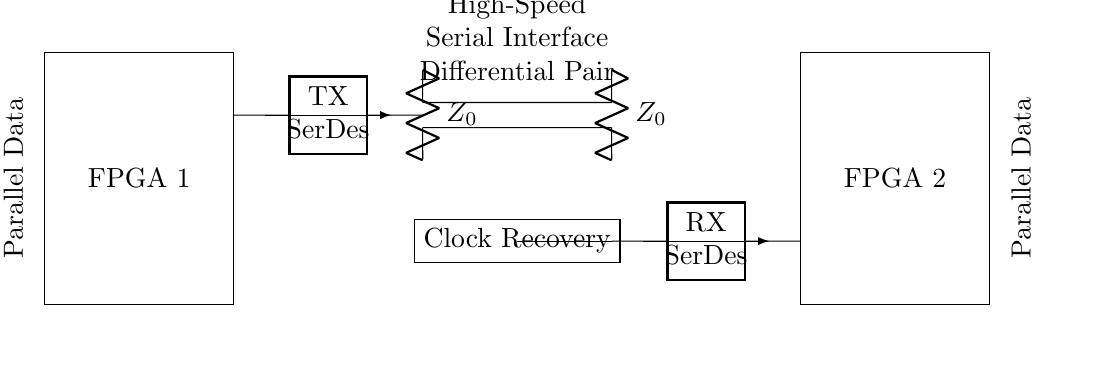What types of FPGAs are in the diagram? The circuit diagram shows two FPGAs labeled as FPGA 1 and FPGA 2. They are each represented as rectangles, and the labeling indicates their functions.
Answer: FPGA 1 and FPGA 2 What is the purpose of the SerDes in this circuit? The SerDes shown in the circuit diagram is responsible for serializing and deserializing data. This is indicated by the labels TX for the transmitter and RX for the receiver, which highlight the direction of data flow.
Answer: Serializing and deserializing data What does the "Differential Pair" signify? The "Differential Pair" refers to two signal lines used to transmit data differentially, which is seen in the two short connections between the SerDes of FPGA 1 and FPGA 2. This is a common technique to improve signal integrity.
Answer: Differential signaling How is impedance matching achieved in this circuit? Impedance matching is achieved using resistors labeled as Z0 connected to the differential pair lines. This helps to minimize reflections and maximize power transfer, which is vital in high-speed communication.
Answer: Resistors labeled Z0 What components are used for clock recovery in this design? The diagram indicates a component labeled "Clock Recovery." This component is essential for extracting the clock signal from the incoming serial data stream, allowing synchronization between the FPGAs.
Answer: Clock Recovery component What type of data flow is indicated by arrows in the circuit? The arrows in the circuit show the direction of data flow, indicating that data is transmitted from FPGA 1 to FPGA 2. This is marked by the arrows pointing from the TX SerDes to the RX SerDes.
Answer: Forward direction from FPGA 1 to FPGA 2 